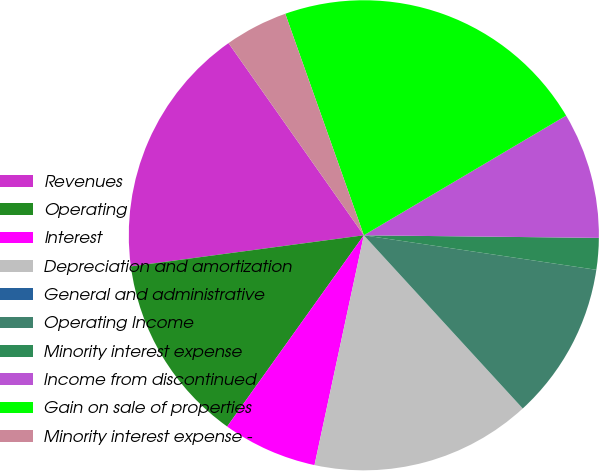Convert chart to OTSL. <chart><loc_0><loc_0><loc_500><loc_500><pie_chart><fcel>Revenues<fcel>Operating<fcel>Interest<fcel>Depreciation and amortization<fcel>General and administrative<fcel>Operating Income<fcel>Minority interest expense<fcel>Income from discontinued<fcel>Gain on sale of properties<fcel>Minority interest expense -<nl><fcel>17.35%<fcel>13.01%<fcel>6.51%<fcel>15.18%<fcel>0.0%<fcel>10.84%<fcel>2.17%<fcel>8.68%<fcel>21.92%<fcel>4.34%<nl></chart> 